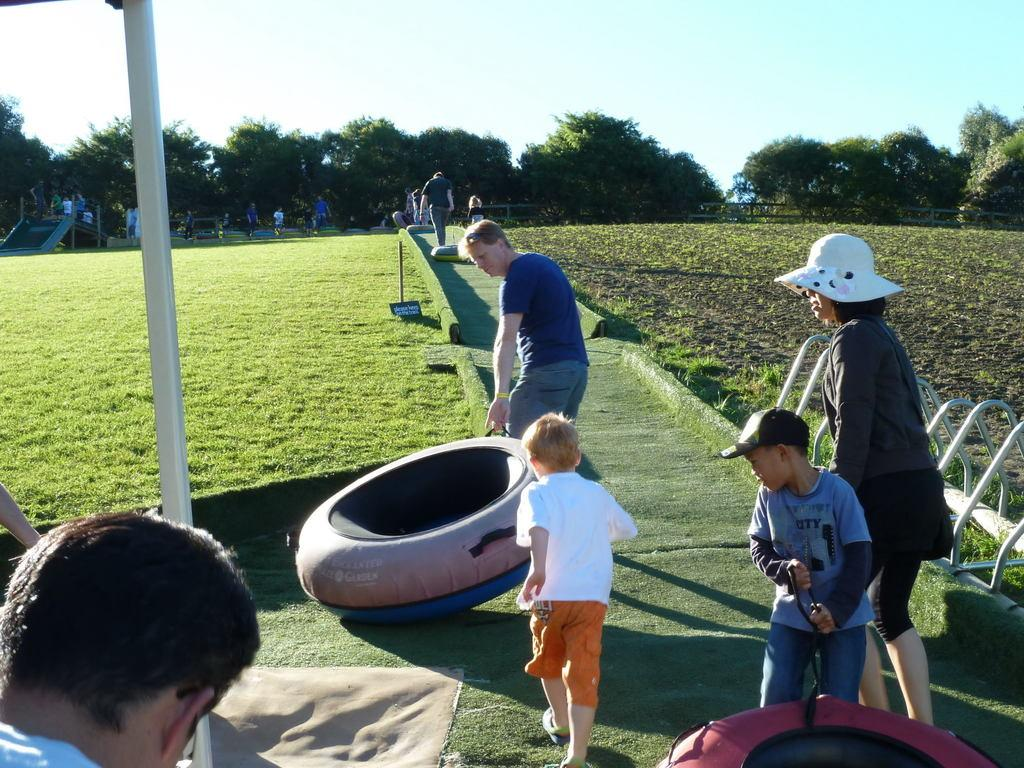What is the main subject of the image? There is a person standing in the image. What is the person holding in his hand? The person is holding an object in his hand. Can you describe the people behind the standing person? There are other people behind the standing person. What is the ground covered with in the image? The ground appears to be covered in greenery. What can be seen in the background of the image? There are trees in the background of the image. Is the person standing in a tub in the image? No, there is no tub present in the image. Can you tell me how deep the quicksand is in the image? There is no quicksand present in the image. 